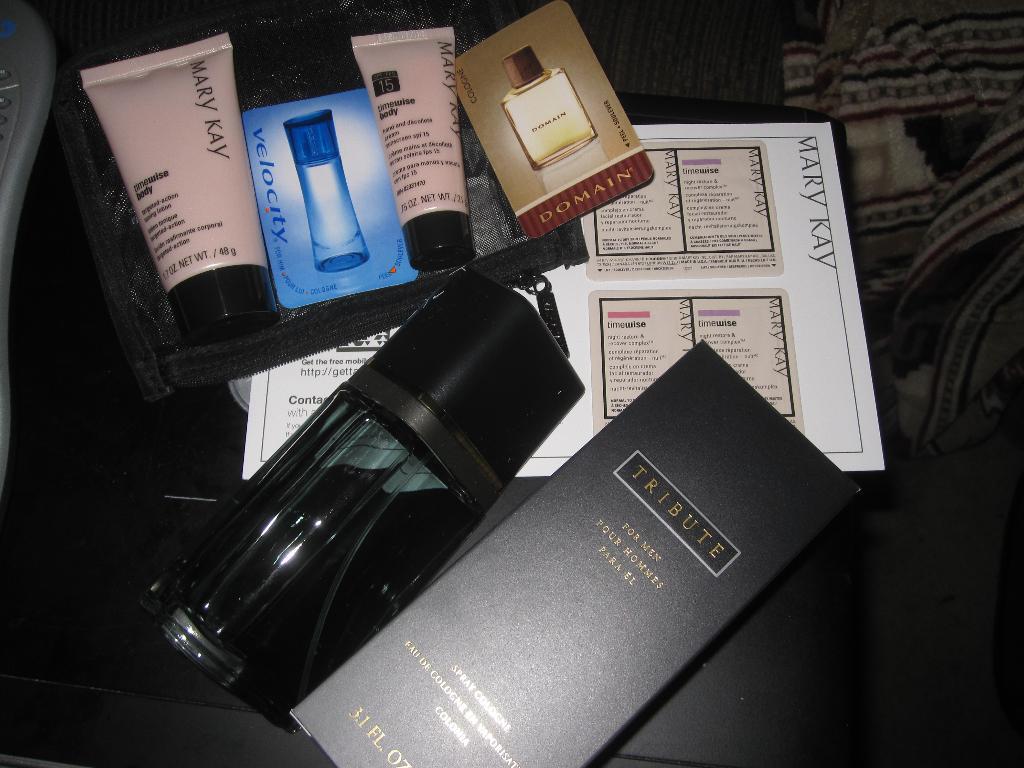What brand are the products in the pink tubes?
Give a very brief answer. Mary kay. Are these mainly female products?
Give a very brief answer. Yes. 